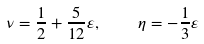<formula> <loc_0><loc_0><loc_500><loc_500>\nu = \frac { 1 } { 2 } + \frac { 5 } { 1 2 } \varepsilon , \quad \eta = - \frac { 1 } { 3 } \varepsilon</formula> 